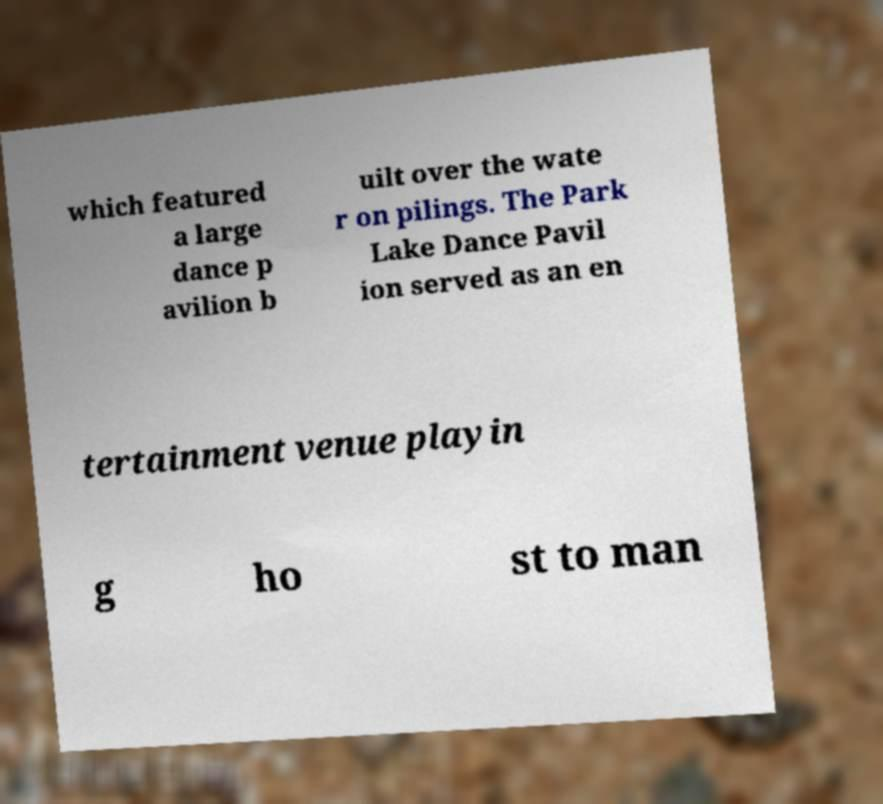Please identify and transcribe the text found in this image. which featured a large dance p avilion b uilt over the wate r on pilings. The Park Lake Dance Pavil ion served as an en tertainment venue playin g ho st to man 